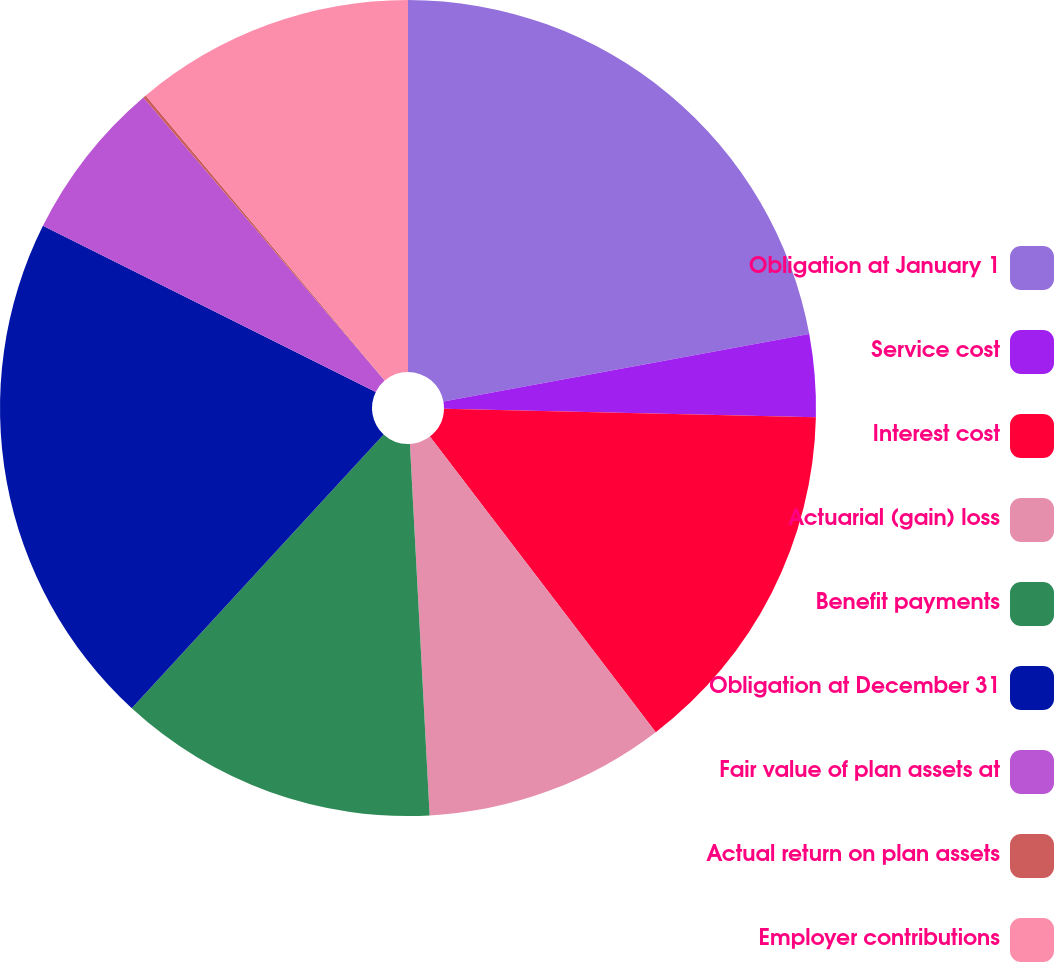<chart> <loc_0><loc_0><loc_500><loc_500><pie_chart><fcel>Obligation at January 1<fcel>Service cost<fcel>Interest cost<fcel>Actuarial (gain) loss<fcel>Benefit payments<fcel>Obligation at December 31<fcel>Fair value of plan assets at<fcel>Actual return on plan assets<fcel>Employer contributions<nl><fcel>22.1%<fcel>3.26%<fcel>14.25%<fcel>9.54%<fcel>12.68%<fcel>20.53%<fcel>6.4%<fcel>0.12%<fcel>11.11%<nl></chart> 